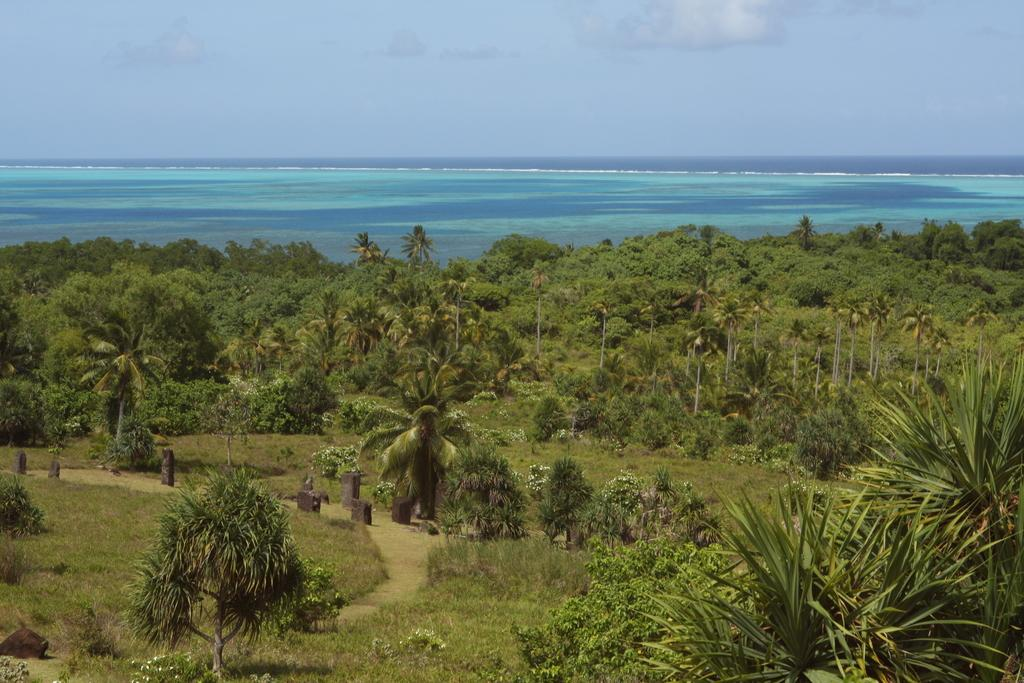What type of vegetation can be seen in the image? There are many trees, plants, and grass in the image. What type of terrain is present in the image? There are stones in the image, which suggests a rocky or uneven terrain. What body of water is visible in the image? There is a sea in the image. What is visible in the background of the image? The sky is visible in the background of the image, with clouds present. What letter is being used as bait to catch the dogs in the image? There are no letters, bait, or dogs present in the image. 